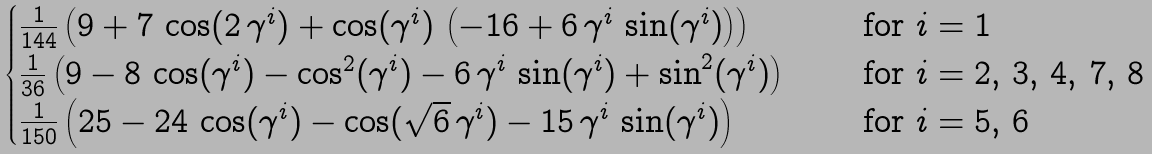<formula> <loc_0><loc_0><loc_500><loc_500>\begin{cases} \frac { 1 } { 1 4 4 } \left ( { 9 + 7 \, \cos ( 2 \, \gamma ^ { i } ) + \cos ( \gamma ^ { i } ) \, \left ( - 1 6 + 6 \, \gamma ^ { i } \, \sin ( \gamma ^ { i } ) \right ) } \right ) & \quad \text { for $i=1 $} \\ \frac { 1 } { 3 6 } \left ( 9 - 8 \, \cos ( \gamma ^ { i } ) - { \cos ^ { 2 } ( \gamma ^ { i } ) } - 6 \, \gamma ^ { i } \, \sin ( \gamma ^ { i } ) + { \sin ^ { 2 } ( \gamma ^ { i } ) } \right ) & \quad \text { for $i=2,\, 3 , \, 4, \, 7, \, 8 $} \\ \frac { 1 } { 1 5 0 } \left ( 2 5 - 2 4 \, \cos ( \gamma ^ { i } ) - \cos ( { \sqrt { 6 } } \, \gamma ^ { i } ) - 1 5 \, \gamma ^ { i } \, \sin ( \gamma ^ { i } ) \right ) & \quad \text { for $i=5, \, 6 $} \end{cases}</formula> 